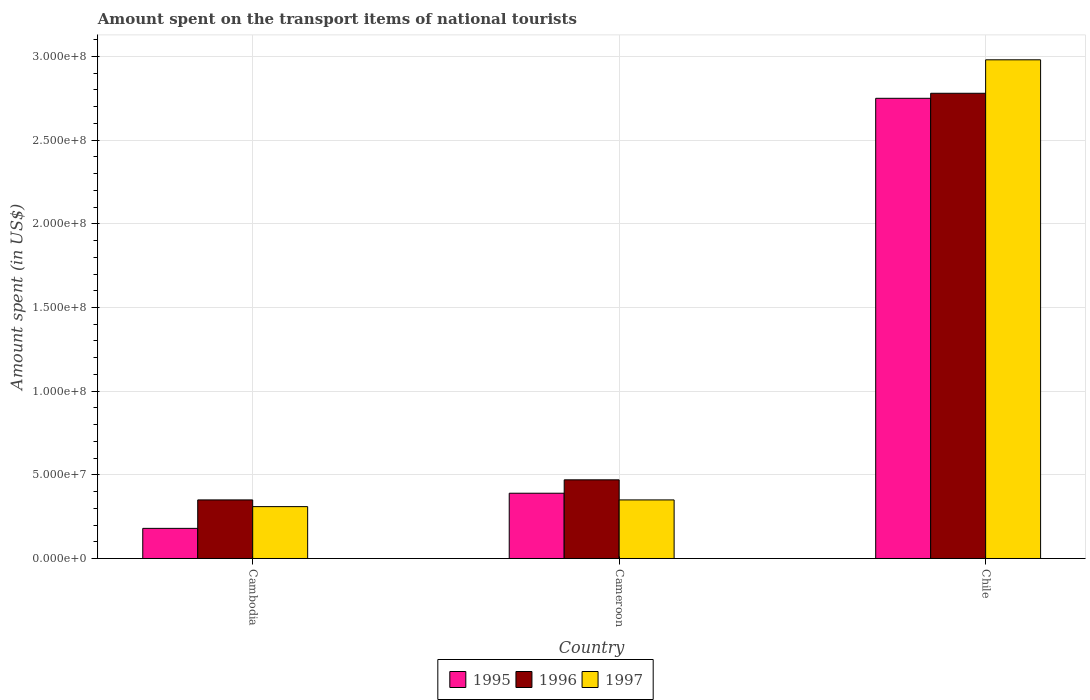Are the number of bars per tick equal to the number of legend labels?
Your response must be concise. Yes. How many bars are there on the 3rd tick from the left?
Give a very brief answer. 3. In how many cases, is the number of bars for a given country not equal to the number of legend labels?
Make the answer very short. 0. What is the amount spent on the transport items of national tourists in 1995 in Cambodia?
Your answer should be very brief. 1.80e+07. Across all countries, what is the maximum amount spent on the transport items of national tourists in 1996?
Give a very brief answer. 2.78e+08. Across all countries, what is the minimum amount spent on the transport items of national tourists in 1995?
Your answer should be very brief. 1.80e+07. In which country was the amount spent on the transport items of national tourists in 1995 minimum?
Make the answer very short. Cambodia. What is the total amount spent on the transport items of national tourists in 1996 in the graph?
Keep it short and to the point. 3.60e+08. What is the difference between the amount spent on the transport items of national tourists in 1995 in Cameroon and that in Chile?
Keep it short and to the point. -2.36e+08. What is the difference between the amount spent on the transport items of national tourists in 1995 in Cambodia and the amount spent on the transport items of national tourists in 1996 in Cameroon?
Your response must be concise. -2.90e+07. What is the average amount spent on the transport items of national tourists in 1996 per country?
Give a very brief answer. 1.20e+08. What is the difference between the amount spent on the transport items of national tourists of/in 1995 and amount spent on the transport items of national tourists of/in 1997 in Cameroon?
Ensure brevity in your answer.  4.00e+06. What is the ratio of the amount spent on the transport items of national tourists in 1995 in Cambodia to that in Chile?
Keep it short and to the point. 0.07. What is the difference between the highest and the second highest amount spent on the transport items of national tourists in 1995?
Make the answer very short. 2.57e+08. What is the difference between the highest and the lowest amount spent on the transport items of national tourists in 1995?
Make the answer very short. 2.57e+08. Is the sum of the amount spent on the transport items of national tourists in 1995 in Cameroon and Chile greater than the maximum amount spent on the transport items of national tourists in 1997 across all countries?
Ensure brevity in your answer.  Yes. What does the 2nd bar from the left in Cameroon represents?
Your response must be concise. 1996. How many countries are there in the graph?
Your answer should be compact. 3. Are the values on the major ticks of Y-axis written in scientific E-notation?
Make the answer very short. Yes. Does the graph contain any zero values?
Make the answer very short. No. Does the graph contain grids?
Make the answer very short. Yes. What is the title of the graph?
Keep it short and to the point. Amount spent on the transport items of national tourists. Does "2013" appear as one of the legend labels in the graph?
Ensure brevity in your answer.  No. What is the label or title of the Y-axis?
Offer a terse response. Amount spent (in US$). What is the Amount spent (in US$) of 1995 in Cambodia?
Offer a terse response. 1.80e+07. What is the Amount spent (in US$) in 1996 in Cambodia?
Your answer should be very brief. 3.50e+07. What is the Amount spent (in US$) of 1997 in Cambodia?
Give a very brief answer. 3.10e+07. What is the Amount spent (in US$) of 1995 in Cameroon?
Provide a short and direct response. 3.90e+07. What is the Amount spent (in US$) of 1996 in Cameroon?
Your answer should be compact. 4.70e+07. What is the Amount spent (in US$) of 1997 in Cameroon?
Your answer should be compact. 3.50e+07. What is the Amount spent (in US$) in 1995 in Chile?
Keep it short and to the point. 2.75e+08. What is the Amount spent (in US$) in 1996 in Chile?
Your answer should be compact. 2.78e+08. What is the Amount spent (in US$) of 1997 in Chile?
Ensure brevity in your answer.  2.98e+08. Across all countries, what is the maximum Amount spent (in US$) in 1995?
Your answer should be compact. 2.75e+08. Across all countries, what is the maximum Amount spent (in US$) of 1996?
Offer a terse response. 2.78e+08. Across all countries, what is the maximum Amount spent (in US$) of 1997?
Ensure brevity in your answer.  2.98e+08. Across all countries, what is the minimum Amount spent (in US$) in 1995?
Keep it short and to the point. 1.80e+07. Across all countries, what is the minimum Amount spent (in US$) in 1996?
Provide a short and direct response. 3.50e+07. Across all countries, what is the minimum Amount spent (in US$) in 1997?
Offer a terse response. 3.10e+07. What is the total Amount spent (in US$) in 1995 in the graph?
Your answer should be compact. 3.32e+08. What is the total Amount spent (in US$) of 1996 in the graph?
Provide a succinct answer. 3.60e+08. What is the total Amount spent (in US$) in 1997 in the graph?
Your answer should be very brief. 3.64e+08. What is the difference between the Amount spent (in US$) of 1995 in Cambodia and that in Cameroon?
Your response must be concise. -2.10e+07. What is the difference between the Amount spent (in US$) of 1996 in Cambodia and that in Cameroon?
Your response must be concise. -1.20e+07. What is the difference between the Amount spent (in US$) in 1997 in Cambodia and that in Cameroon?
Offer a terse response. -4.00e+06. What is the difference between the Amount spent (in US$) in 1995 in Cambodia and that in Chile?
Offer a terse response. -2.57e+08. What is the difference between the Amount spent (in US$) of 1996 in Cambodia and that in Chile?
Make the answer very short. -2.43e+08. What is the difference between the Amount spent (in US$) in 1997 in Cambodia and that in Chile?
Keep it short and to the point. -2.67e+08. What is the difference between the Amount spent (in US$) of 1995 in Cameroon and that in Chile?
Offer a very short reply. -2.36e+08. What is the difference between the Amount spent (in US$) in 1996 in Cameroon and that in Chile?
Offer a very short reply. -2.31e+08. What is the difference between the Amount spent (in US$) in 1997 in Cameroon and that in Chile?
Ensure brevity in your answer.  -2.63e+08. What is the difference between the Amount spent (in US$) of 1995 in Cambodia and the Amount spent (in US$) of 1996 in Cameroon?
Your answer should be compact. -2.90e+07. What is the difference between the Amount spent (in US$) of 1995 in Cambodia and the Amount spent (in US$) of 1997 in Cameroon?
Provide a succinct answer. -1.70e+07. What is the difference between the Amount spent (in US$) in 1995 in Cambodia and the Amount spent (in US$) in 1996 in Chile?
Provide a succinct answer. -2.60e+08. What is the difference between the Amount spent (in US$) of 1995 in Cambodia and the Amount spent (in US$) of 1997 in Chile?
Make the answer very short. -2.80e+08. What is the difference between the Amount spent (in US$) in 1996 in Cambodia and the Amount spent (in US$) in 1997 in Chile?
Offer a very short reply. -2.63e+08. What is the difference between the Amount spent (in US$) of 1995 in Cameroon and the Amount spent (in US$) of 1996 in Chile?
Keep it short and to the point. -2.39e+08. What is the difference between the Amount spent (in US$) of 1995 in Cameroon and the Amount spent (in US$) of 1997 in Chile?
Offer a terse response. -2.59e+08. What is the difference between the Amount spent (in US$) in 1996 in Cameroon and the Amount spent (in US$) in 1997 in Chile?
Give a very brief answer. -2.51e+08. What is the average Amount spent (in US$) in 1995 per country?
Give a very brief answer. 1.11e+08. What is the average Amount spent (in US$) of 1996 per country?
Provide a succinct answer. 1.20e+08. What is the average Amount spent (in US$) of 1997 per country?
Your response must be concise. 1.21e+08. What is the difference between the Amount spent (in US$) of 1995 and Amount spent (in US$) of 1996 in Cambodia?
Provide a short and direct response. -1.70e+07. What is the difference between the Amount spent (in US$) of 1995 and Amount spent (in US$) of 1997 in Cambodia?
Keep it short and to the point. -1.30e+07. What is the difference between the Amount spent (in US$) in 1995 and Amount spent (in US$) in 1996 in Cameroon?
Make the answer very short. -8.00e+06. What is the difference between the Amount spent (in US$) in 1995 and Amount spent (in US$) in 1997 in Cameroon?
Provide a short and direct response. 4.00e+06. What is the difference between the Amount spent (in US$) of 1996 and Amount spent (in US$) of 1997 in Cameroon?
Your response must be concise. 1.20e+07. What is the difference between the Amount spent (in US$) of 1995 and Amount spent (in US$) of 1996 in Chile?
Ensure brevity in your answer.  -3.00e+06. What is the difference between the Amount spent (in US$) in 1995 and Amount spent (in US$) in 1997 in Chile?
Offer a very short reply. -2.30e+07. What is the difference between the Amount spent (in US$) of 1996 and Amount spent (in US$) of 1997 in Chile?
Offer a very short reply. -2.00e+07. What is the ratio of the Amount spent (in US$) of 1995 in Cambodia to that in Cameroon?
Your answer should be very brief. 0.46. What is the ratio of the Amount spent (in US$) in 1996 in Cambodia to that in Cameroon?
Provide a short and direct response. 0.74. What is the ratio of the Amount spent (in US$) in 1997 in Cambodia to that in Cameroon?
Offer a terse response. 0.89. What is the ratio of the Amount spent (in US$) of 1995 in Cambodia to that in Chile?
Offer a very short reply. 0.07. What is the ratio of the Amount spent (in US$) in 1996 in Cambodia to that in Chile?
Keep it short and to the point. 0.13. What is the ratio of the Amount spent (in US$) of 1997 in Cambodia to that in Chile?
Your answer should be very brief. 0.1. What is the ratio of the Amount spent (in US$) in 1995 in Cameroon to that in Chile?
Provide a succinct answer. 0.14. What is the ratio of the Amount spent (in US$) of 1996 in Cameroon to that in Chile?
Give a very brief answer. 0.17. What is the ratio of the Amount spent (in US$) of 1997 in Cameroon to that in Chile?
Offer a very short reply. 0.12. What is the difference between the highest and the second highest Amount spent (in US$) in 1995?
Ensure brevity in your answer.  2.36e+08. What is the difference between the highest and the second highest Amount spent (in US$) of 1996?
Offer a terse response. 2.31e+08. What is the difference between the highest and the second highest Amount spent (in US$) of 1997?
Provide a succinct answer. 2.63e+08. What is the difference between the highest and the lowest Amount spent (in US$) in 1995?
Your answer should be very brief. 2.57e+08. What is the difference between the highest and the lowest Amount spent (in US$) of 1996?
Provide a short and direct response. 2.43e+08. What is the difference between the highest and the lowest Amount spent (in US$) of 1997?
Give a very brief answer. 2.67e+08. 